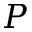Convert formula to latex. <formula><loc_0><loc_0><loc_500><loc_500>P</formula> 